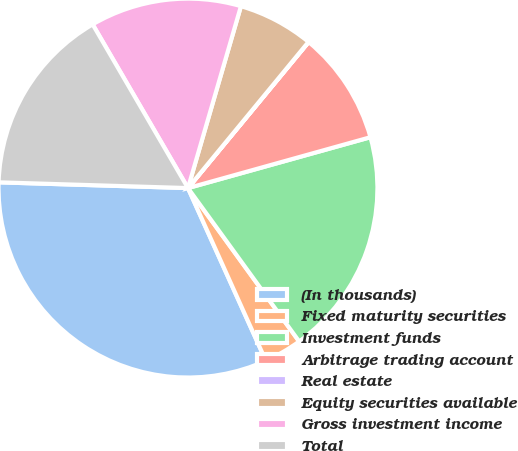<chart> <loc_0><loc_0><loc_500><loc_500><pie_chart><fcel>(In thousands)<fcel>Fixed maturity securities<fcel>Investment funds<fcel>Arbitrage trading account<fcel>Real estate<fcel>Equity securities available<fcel>Gross investment income<fcel>Total<nl><fcel>32.22%<fcel>3.24%<fcel>19.34%<fcel>9.68%<fcel>0.02%<fcel>6.46%<fcel>12.9%<fcel>16.12%<nl></chart> 